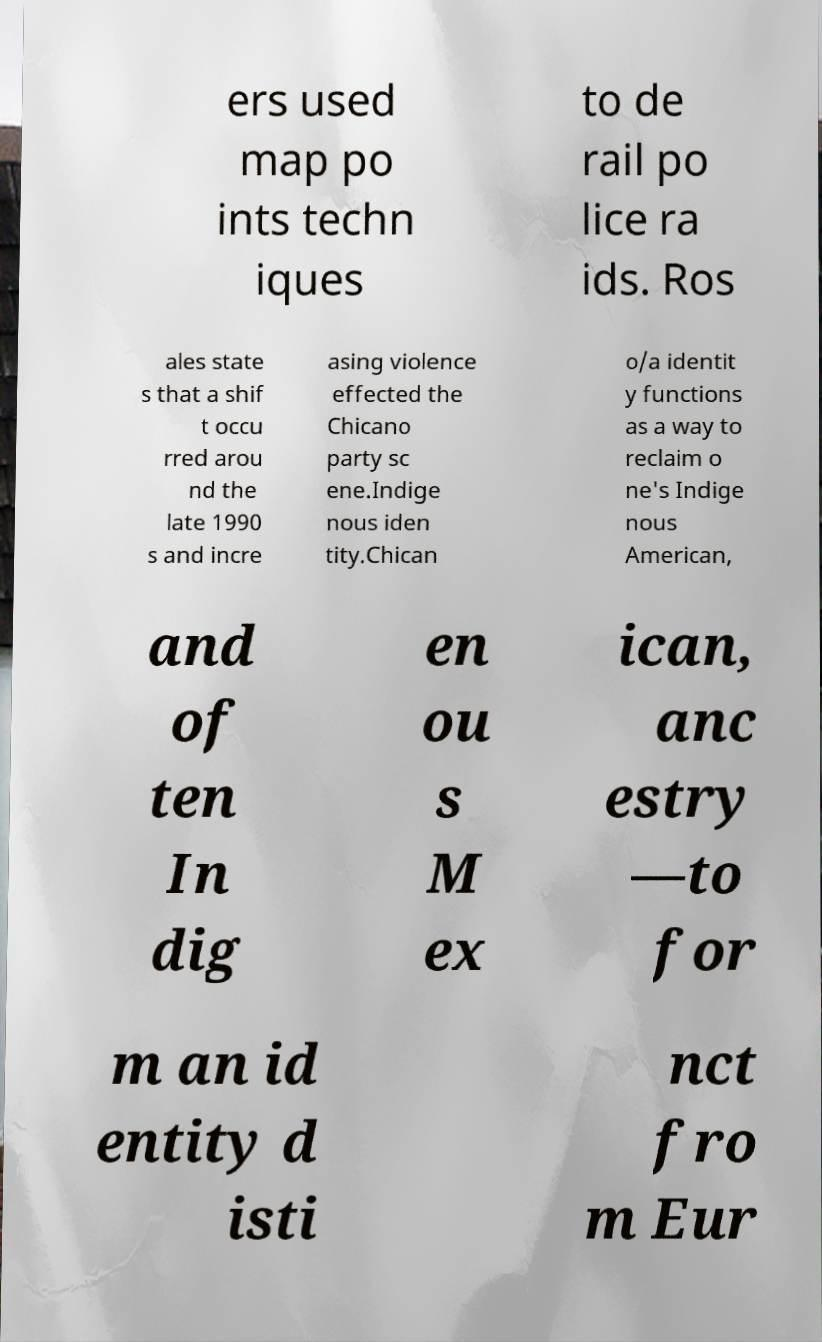There's text embedded in this image that I need extracted. Can you transcribe it verbatim? ers used map po ints techn iques to de rail po lice ra ids. Ros ales state s that a shif t occu rred arou nd the late 1990 s and incre asing violence effected the Chicano party sc ene.Indige nous iden tity.Chican o/a identit y functions as a way to reclaim o ne's Indige nous American, and of ten In dig en ou s M ex ican, anc estry —to for m an id entity d isti nct fro m Eur 